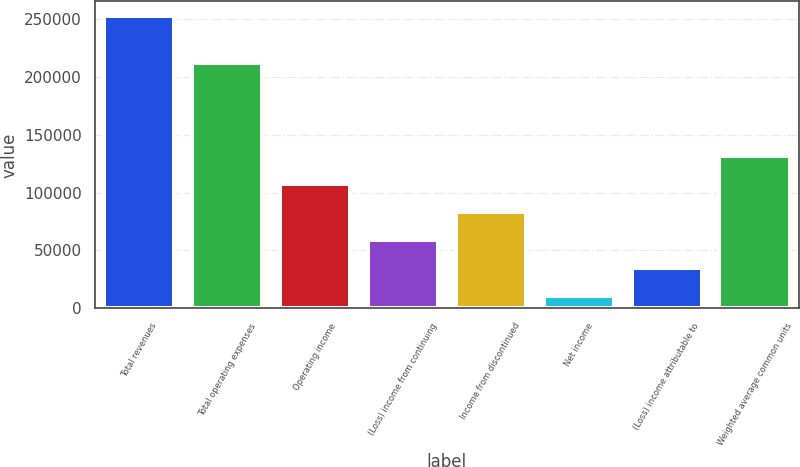Convert chart to OTSL. <chart><loc_0><loc_0><loc_500><loc_500><bar_chart><fcel>Total revenues<fcel>Total operating expenses<fcel>Operating income<fcel>(Loss) income from continuing<fcel>Income from discontinued<fcel>Net income<fcel>(Loss) income attributable to<fcel>Weighted average common units<nl><fcel>252610<fcel>212415<fcel>107432<fcel>59039.6<fcel>83235.9<fcel>10647<fcel>34843.3<fcel>131628<nl></chart> 